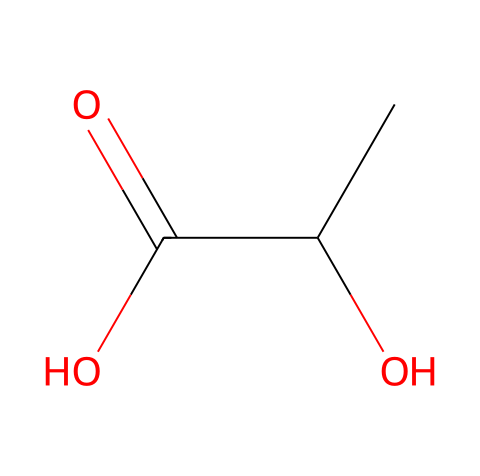What is the chemical name of the compound shown? The SMILES representation indicates that the compound contains a hydroxyl group (-OH) and a carboxylic acid group (-COOH), typical for lactic acid.
Answer: lactic acid How many carbon atoms are in the structure? The structure shows three carbon atoms present in the formula (CC(O)C(=O)O).
Answer: 3 How many functional groups can you identify in lactic acid? By analyzing the structure, we can see two functional groups: a hydroxyl group and a carboxylic acid.
Answer: 2 What type of bond is present between the carbon and oxygen in the -COOH group? The carbon in the carboxylic acid group is connected to oxygen with a double bond (=O), indicating a double bond.
Answer: double bond Does this compound produce an acidic solution in water? The presence of the carboxylic acid functional group (-COOH) indicates that it can donate a proton (H+) in solution, making it acidic.
Answer: yes Is lactic acid an alkaloid? Alkaloids are typically nitrogen-containing compounds with pronounced physiological effects; lactic acid does not contain nitrogen, therefore it is not classified as an alkaloid.
Answer: no Does lactic acid have a chiral center? The structure reveals a carbon atom bonded to four different groups, which makes it a chiral center; thus lactic acid is chiral.
Answer: yes 